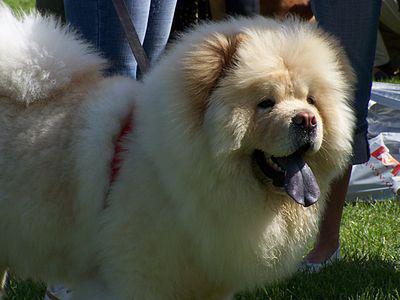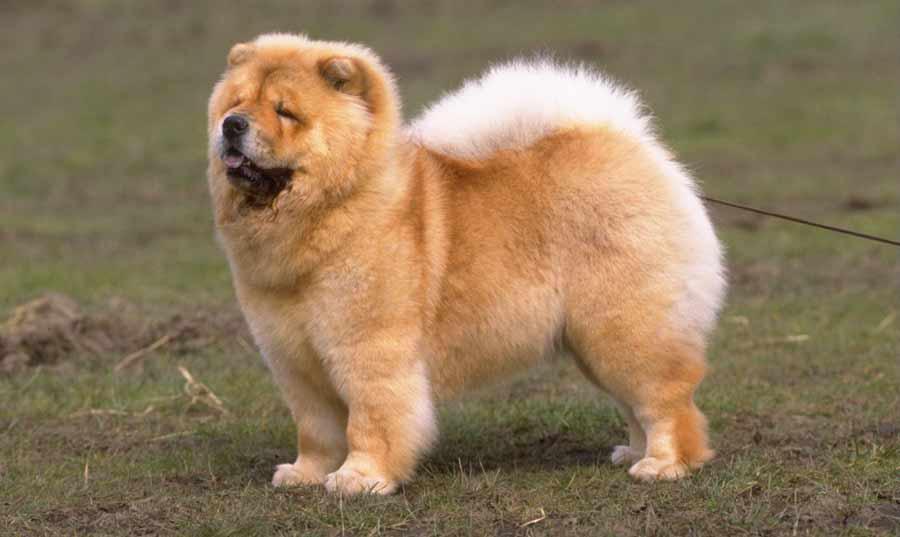The first image is the image on the left, the second image is the image on the right. Assess this claim about the two images: "At least one of the furry dogs is standing in the grass.". Correct or not? Answer yes or no. Yes. The first image is the image on the left, the second image is the image on the right. For the images shown, is this caption "Right image shows a chow dog standing with its body turned leftward." true? Answer yes or no. Yes. 